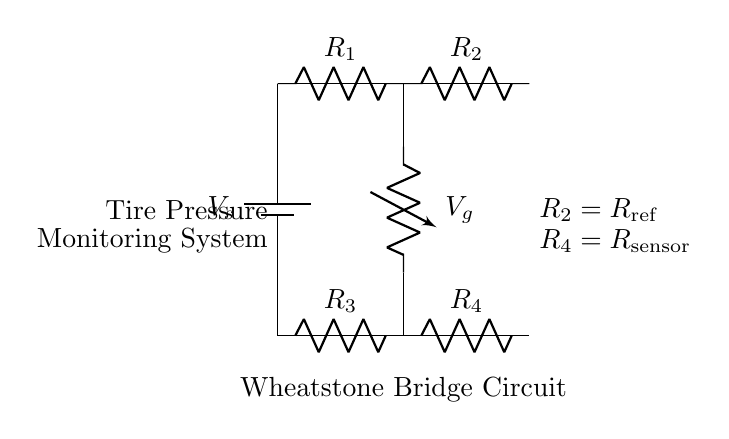What type of circuit is depicted? The circuit shown is a Wheatstone Bridge, which is used for measuring electrical resistance. It consists of four resistors arranged in a specific pattern to allow for balance and measurement.
Answer: Wheatstone Bridge How many resistors are in the circuit? The diagram contains four resistors labeled as R1, R2, R3, and R4. Each resistor plays a role in creating the bridge's function for measurement.
Answer: Four What is the role of R2 in the circuit? R2 is identified as the reference resistor in the Wheatstone Bridge configuration, which helps in comparing the resistance of the sensor, R4, to a known value for precise measurement.
Answer: Reference resistor What does Vg represent in the diagram? Vg indicates the voltage generated across the Wheatstone Bridge, which is used to determine any imbalance in the bridge caused by a change in the tire pressure sensor resistance.
Answer: Voltage generated How does the circuit detect changes in tire pressure? The circuit detects changes in tire pressure by measuring the resistance of R4, the sensor resistor, which varies with tire pressure. When the pressure changes, R4 changes, altering the balance and the output voltage, Vg.
Answer: By measuring resistance Which resistor is variable in this circuit? R4 is the sensor resistor, which changes based on the tire pressure, making it the variable resistor in the Wheatstone Bridge.
Answer: R4 What do the nodes connecting R1, R2, R3, and R4 form? The connections form a full bridge circuit configuration essential for balancing and measuring the difference in resistance between the components. This is the fundamental characteristic of a Wheatstone Bridge.
Answer: A bridge configuration 